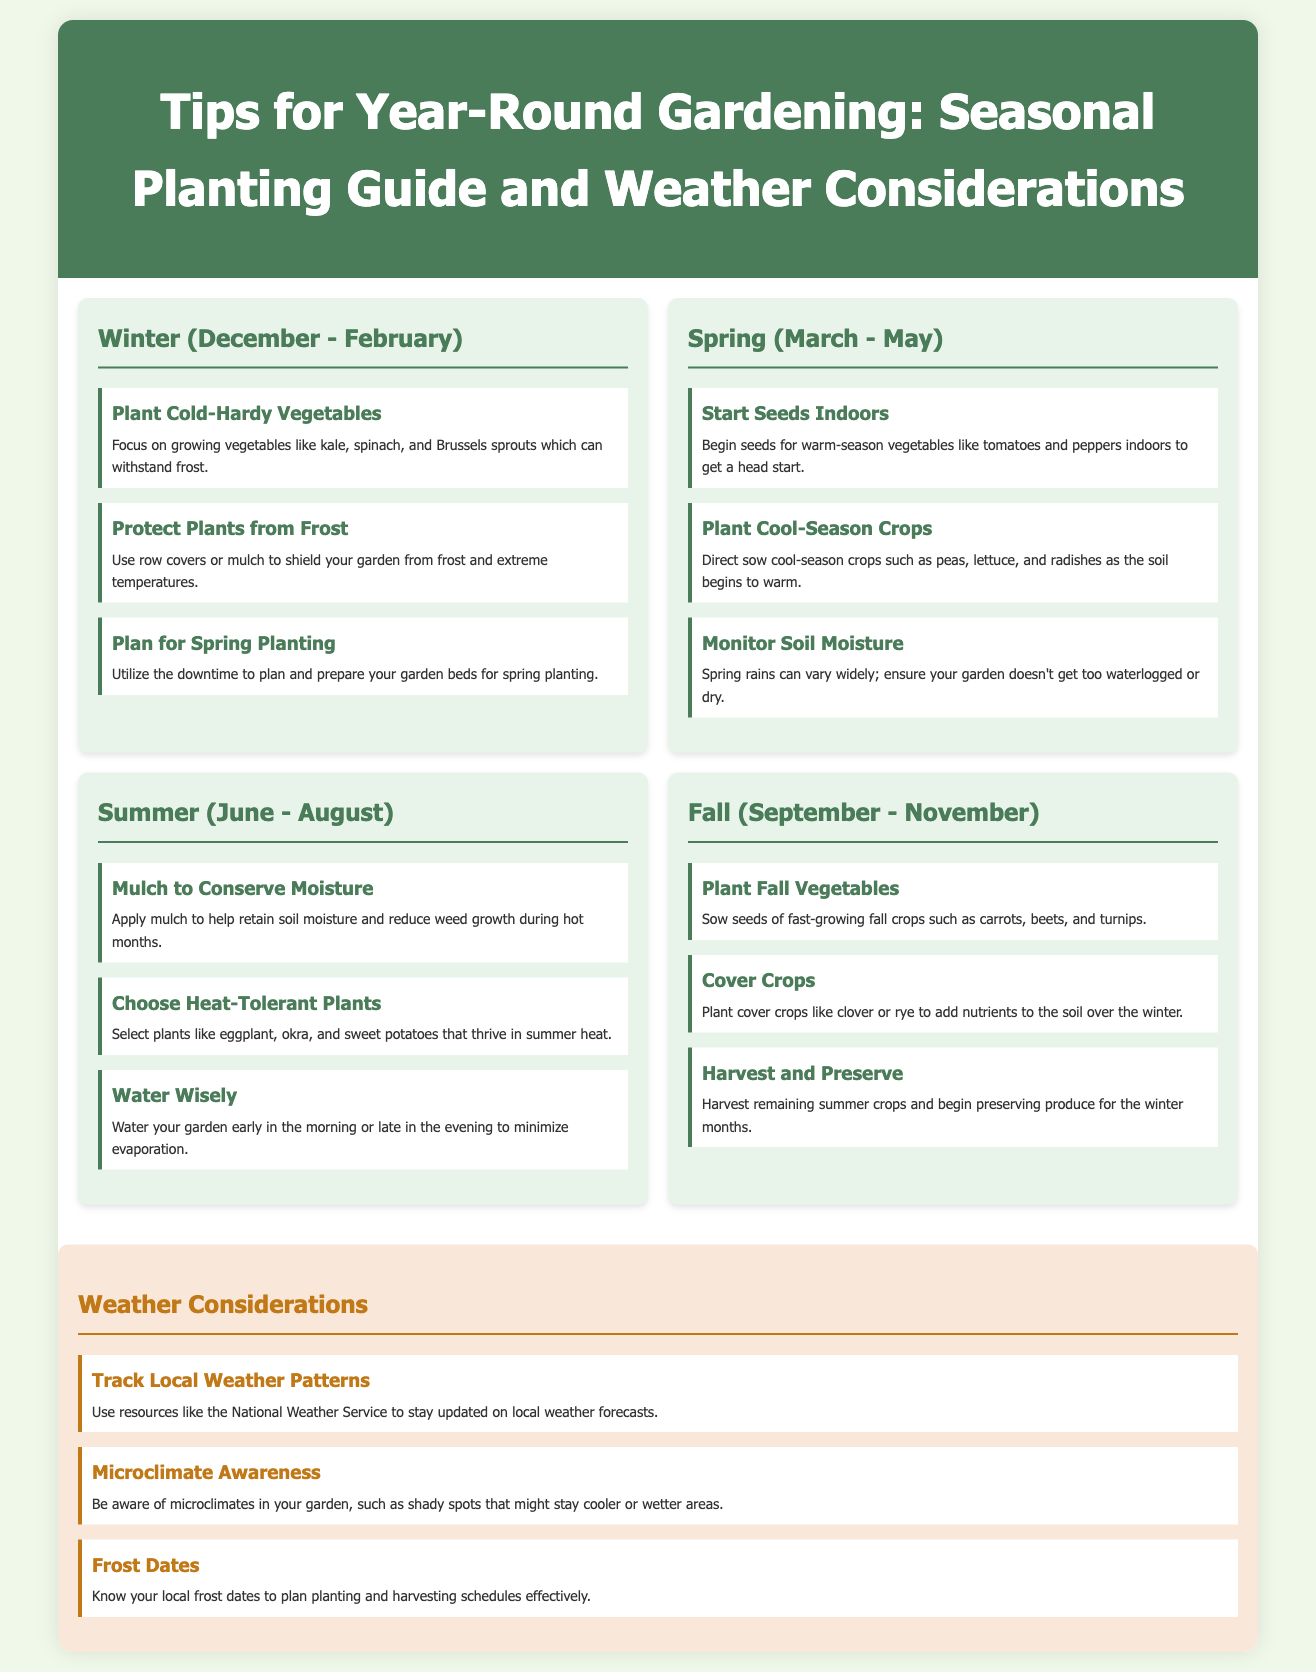What are some cold-hardy vegetables? The document lists kale, spinach, and Brussels sprouts as examples of cold-hardy vegetables.
Answer: kale, spinach, and Brussels sprouts What should you do to protect plants from frost? The infographic suggests using row covers or mulch to shield your garden from frost and extreme temperatures.
Answer: row covers or mulch What is a recommended action for spring planting? The document advises planning and preparing your garden beds for spring planting during winter.
Answer: plan and prepare your garden beds When should you start seeds indoors? The infographic indicates that seeds for warm-season vegetables should be started indoors in early spring.
Answer: early spring What is the main purpose of mulch in the summer? The document states that applying mulch helps retain soil moisture and reduce weed growth during hot months.
Answer: retain soil moisture and reduce weed growth How can you monitor soil moisture in spring? The document notes the importance of ensuring your garden doesn't get too waterlogged or dry during spring rains.
Answer: ensure the garden doesn't get too waterlogged or dry What should you know regarding local frost dates? The infographic emphasizes knowing local frost dates to effectively plan planting and harvesting schedules.
Answer: plan planting and harvesting schedules What are cover crops used for in the fall? The document mentions that cover crops like clover or rye are used to add nutrients to the soil over the winter.
Answer: add nutrients to the soil Why should you track local weather patterns? The document suggests tracking local weather patterns to stay updated on weather forecasts, affecting gardening decisions.
Answer: stay updated on weather forecasts 